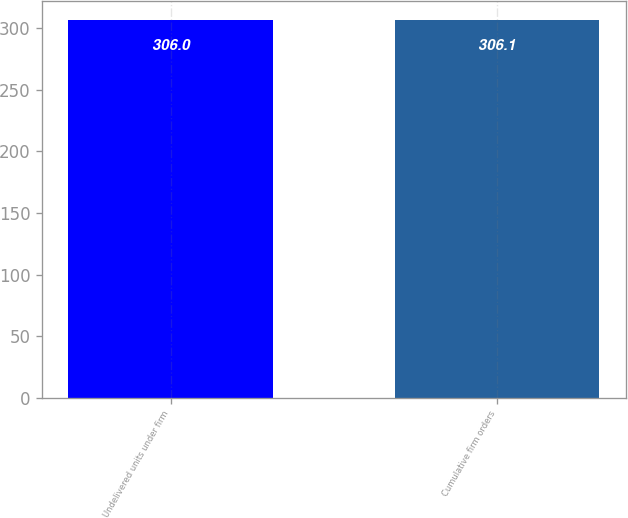<chart> <loc_0><loc_0><loc_500><loc_500><bar_chart><fcel>Undelivered units under firm<fcel>Cumulative firm orders<nl><fcel>306<fcel>306.1<nl></chart> 